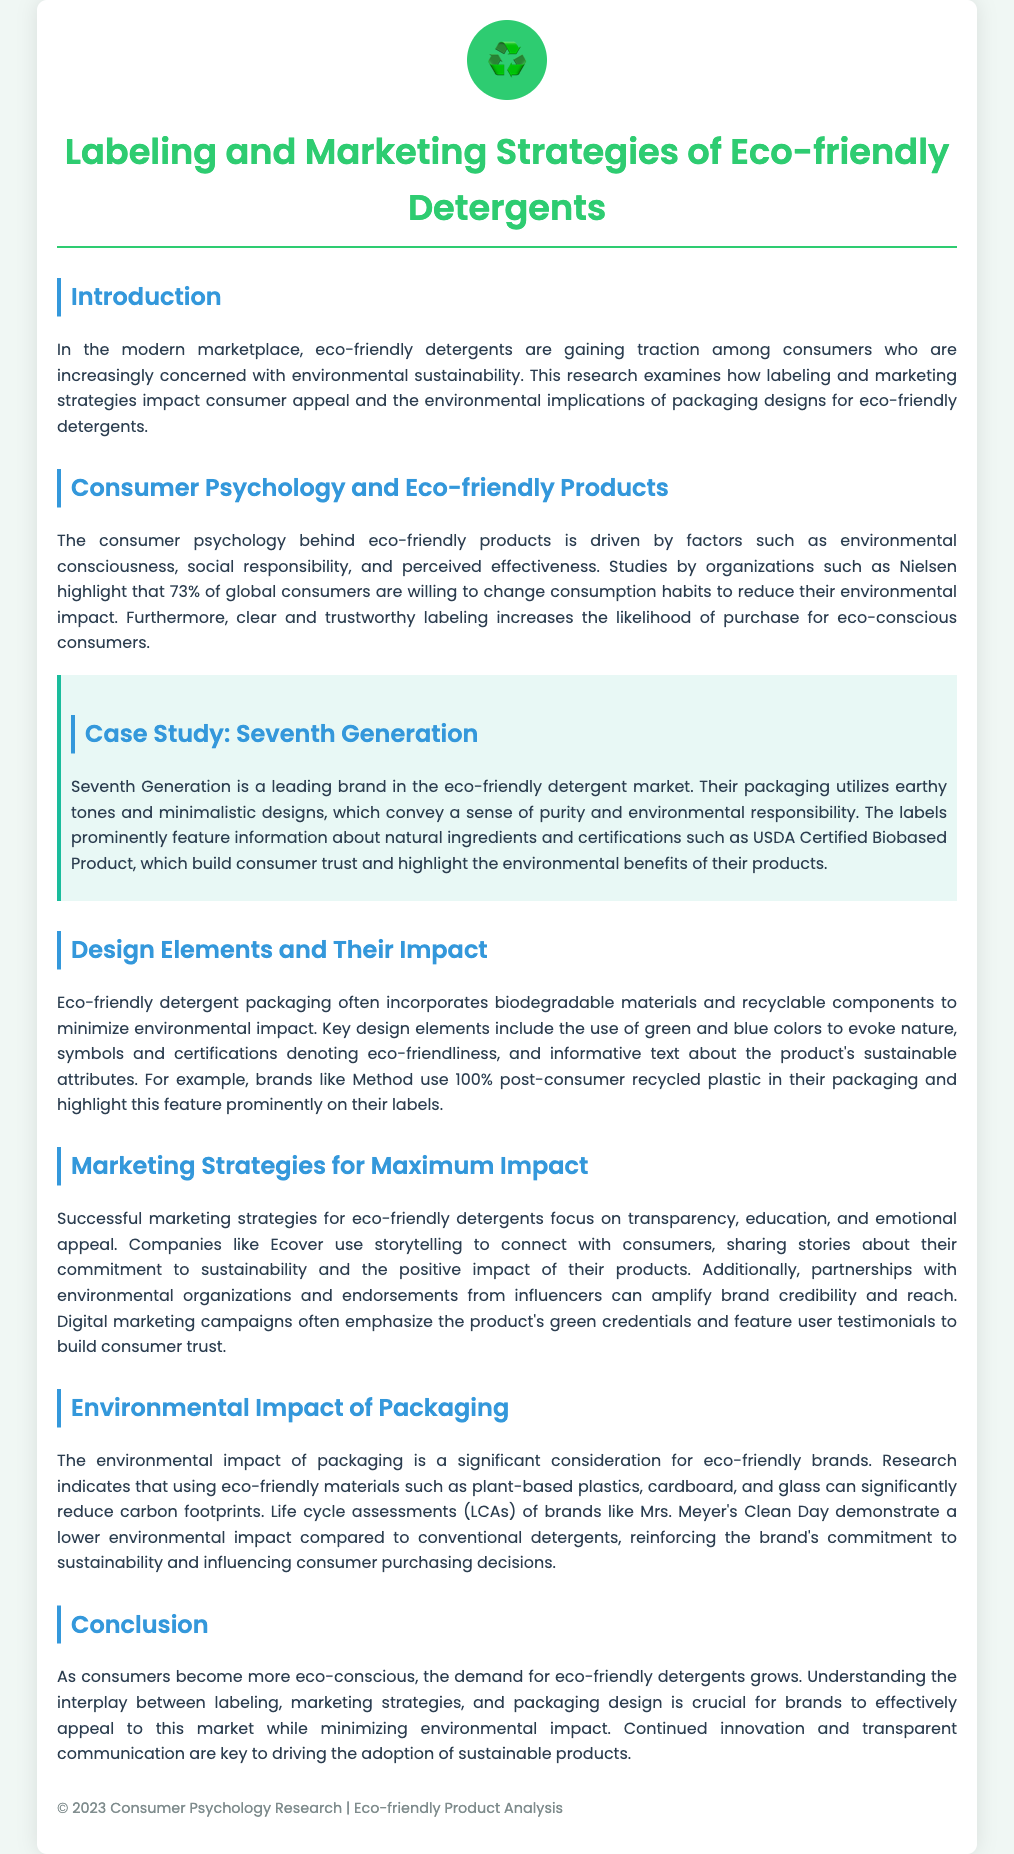What percentage of global consumers are willing to change consumption habits? The document states that 73% of global consumers are willing to change their consumption habits to reduce their environmental impact.
Answer: 73% What certifications are mentioned in connection with Seventh Generation? The document mentions the USDA Certified Biobased Product certification as a trust-building aspect for Seventh Generation's products.
Answer: USDA Certified Biobased Product What key design elements are often used in eco-friendly detergent packaging? The document highlights biodegradable materials, recyclable components, and earthy colors as key design elements in eco-friendly detergent packaging.
Answer: Biodegradable materials, recyclable components, and earthy colors Which company uses 100% post-consumer recycled plastic in their packaging? The document specifies that the brand Method uses 100% post-consumer recycled plastic in their packaging.
Answer: Method What marketing strategy does Ecover use to connect with consumers? The document states that Ecover uses storytelling as a marketing strategy to connect with consumers.
Answer: Storytelling What is highlighted as a significant consideration for eco-friendly brands? The document indicates that the environmental impact of packaging is a significant consideration for eco-friendly brands.
Answer: Environmental impact of packaging What do life cycle assessments compare? The document mentions that life cycle assessments (LCAs) compare the environmental impact of brands like Mrs. Meyer's Clean Day with conventional detergents.
Answer: Environmental impact What is crucial for brands to appeal to eco-conscious consumers? The document suggests that understanding the interplay between labeling, marketing strategies, and packaging design is crucial for brands to appeal to eco-conscious consumers.
Answer: Understanding interplay What year is listed at the bottom of the document? The document lists the year 2023 at the bottom under the copyright notice.
Answer: 2023 